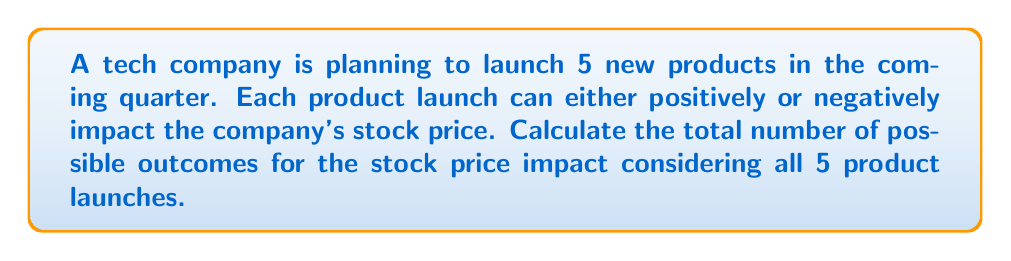Provide a solution to this math problem. To solve this problem, we need to understand the following concepts:

1. Each product launch has two possible outcomes: positive or negative impact on stock price.
2. We have 5 independent product launches.
3. This scenario represents a binary outcome for each event, which can be modeled using the multiplication principle and binary representation.

Step 1: Analyze the possible outcomes for each product launch
For each product launch, there are 2 possible outcomes:
- Positive impact on stock price
- Negative impact on stock price

Step 2: Apply the multiplication principle
Since we have 5 independent product launches, and each launch has 2 possible outcomes, we can calculate the total number of possible outcomes by multiplying:

$$ \text{Total outcomes} = 2 \times 2 \times 2 \times 2 \times 2 = 2^5 $$

Step 3: Calculate the result
$$ 2^5 = 32 $$

Alternatively, we can think of this problem in terms of binary representation:
- Each product launch can be represented by a binary digit (0 for negative impact, 1 for positive impact).
- With 5 product launches, we have a 5-digit binary number.
- The total number of possible 5-digit binary numbers is $2^5 = 32$.

This approach is particularly relevant for a software engineer, as it relates to binary representation in computer systems.
Answer: $$ 32 \text{ possible outcomes} $$ 